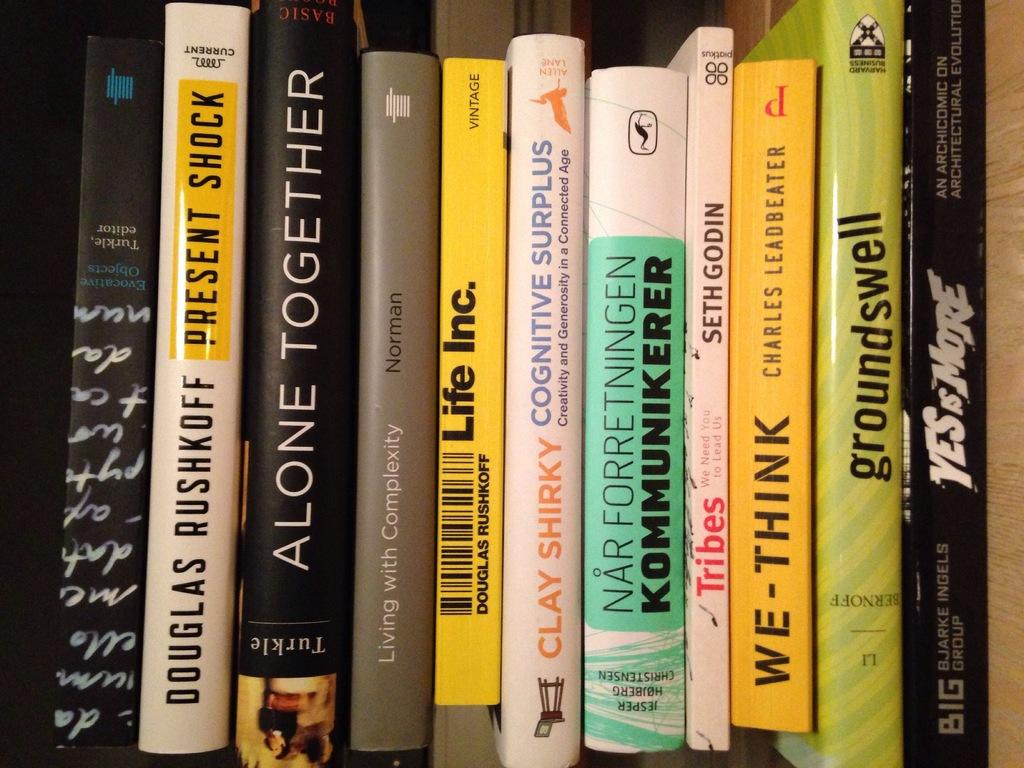What objects are present in the image? There are books in the image. How are the books arranged in the image? The books are placed in a bookshelf. What can be observed about the colors of the books? The books have various colors, including black, brown, yellow, white, and green. Can you describe the text on the books? There is text visible on the books. What type of horse can be seen wearing a chain in the image? There is no horse or chain present in the image; it features books in a bookshelf. 